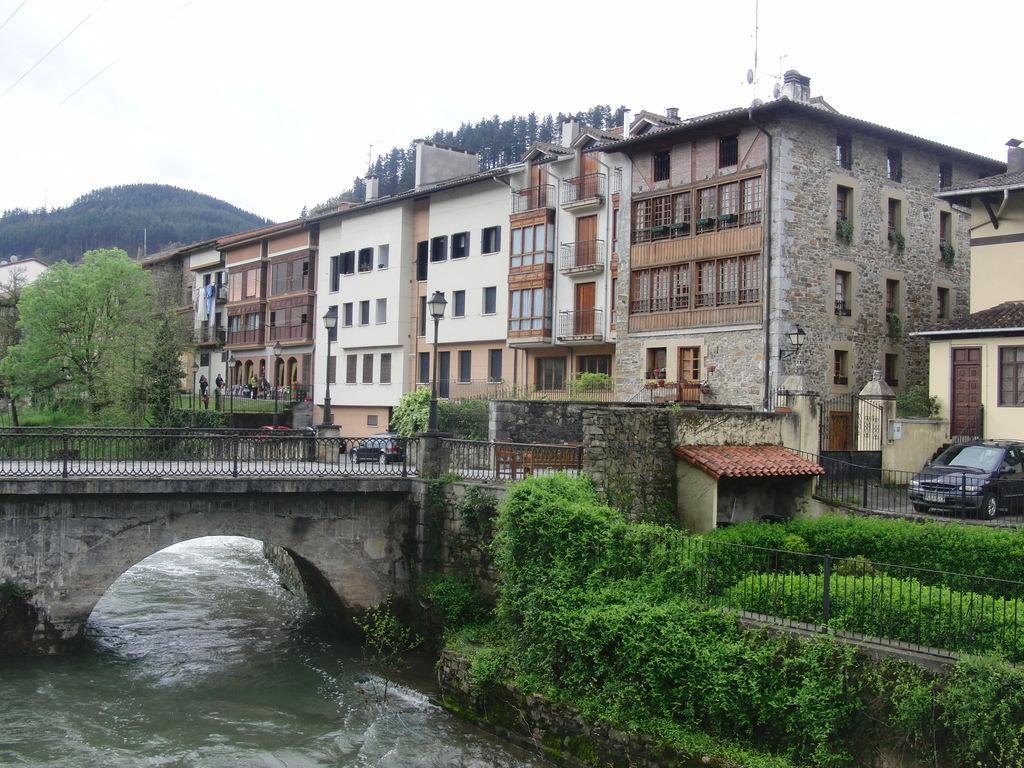Please provide a concise description of this image. In this image there is the water flowing. There is a bridge across the water. There is a railing on the bridge. In the bottom right there are plants and grass on the ground. Behind the bridge there are buildings, trees and street light poles. In the background there are trees and mountains. At the top there is the sky. To the right there is a car parked on the ground. 